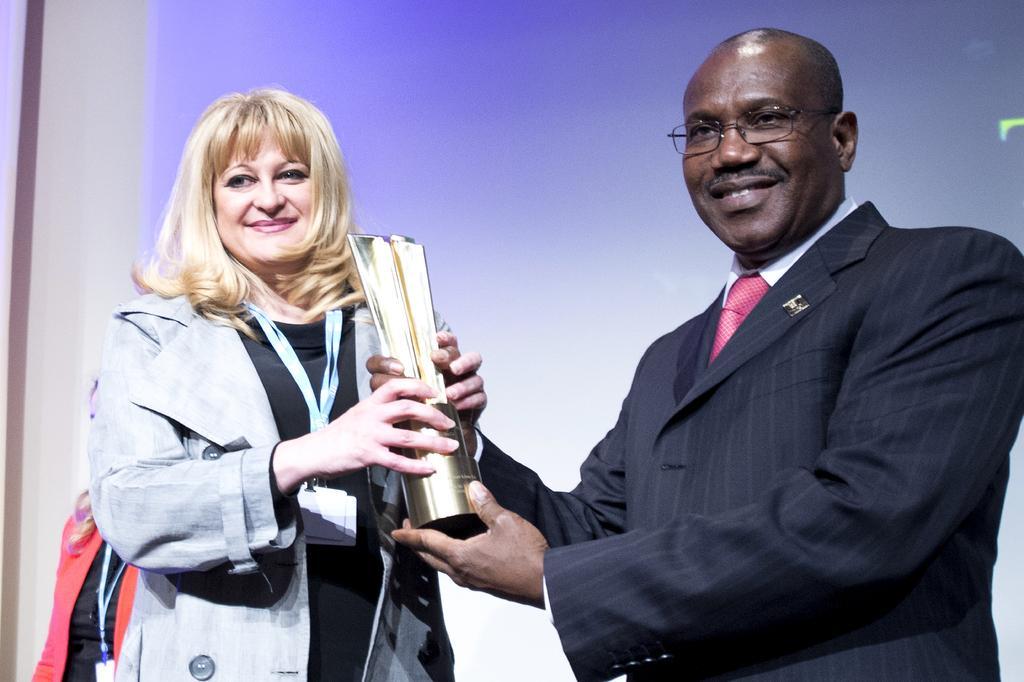How would you summarize this image in a sentence or two? In this picture we can observe a man and a woman holding a prize in their hands. The man is wearing a coat and smiling. The woman is wearing a tag in her neck and smiling. In the background there is a screen. 